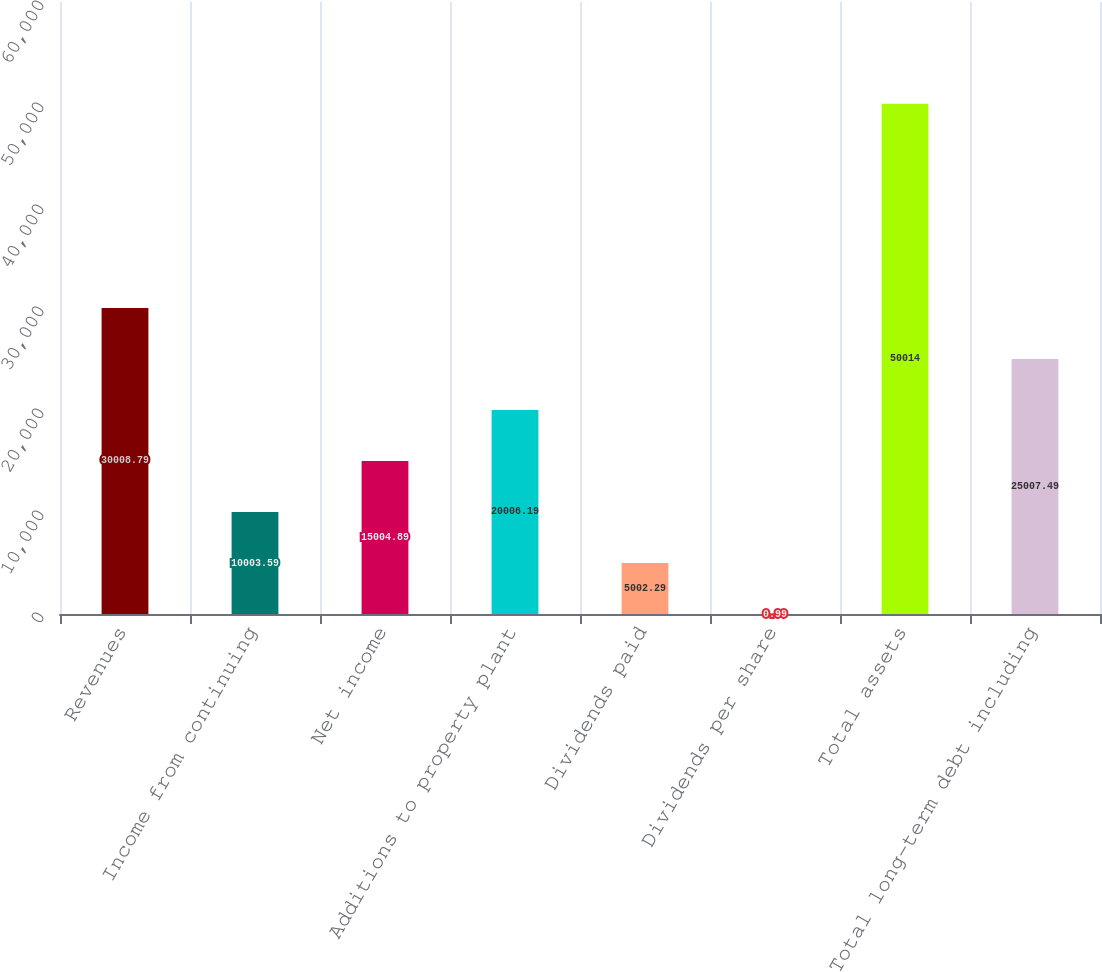Convert chart. <chart><loc_0><loc_0><loc_500><loc_500><bar_chart><fcel>Revenues<fcel>Income from continuing<fcel>Net income<fcel>Additions to property plant<fcel>Dividends paid<fcel>Dividends per share<fcel>Total assets<fcel>Total long-term debt including<nl><fcel>30008.8<fcel>10003.6<fcel>15004.9<fcel>20006.2<fcel>5002.29<fcel>0.99<fcel>50014<fcel>25007.5<nl></chart> 